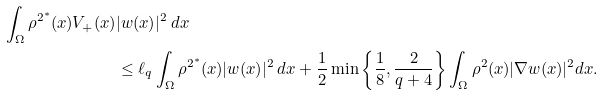<formula> <loc_0><loc_0><loc_500><loc_500>\int _ { \Omega } \rho ^ { 2 ^ { * } } ( x ) V _ { + } ( x ) & | w ( x ) | ^ { 2 } \, d x \\ & \leq \ell _ { q } \int _ { \Omega } \rho ^ { 2 ^ { * } } ( x ) | w ( x ) | ^ { 2 } \, d x + \frac { 1 } { 2 } \min \left \{ \frac { 1 } { 8 } , \frac { 2 } { q + 4 } \right \} \int _ { \Omega } \rho ^ { 2 } ( x ) | \nabla w ( x ) | ^ { 2 } d x .</formula> 